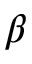Convert formula to latex. <formula><loc_0><loc_0><loc_500><loc_500>\beta</formula> 